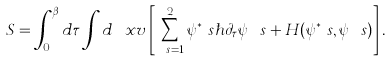Convert formula to latex. <formula><loc_0><loc_0><loc_500><loc_500>S = \int _ { 0 } ^ { \beta } d \tau \int d { \ x v } \left [ \sum _ { \ s = 1 } ^ { 2 } \psi ^ { * } _ { \ } s \hbar { \partial } _ { \tau } \psi _ { \ } s + H ( \psi ^ { * } _ { \ } s , \psi _ { \ } s ) \right ] .</formula> 